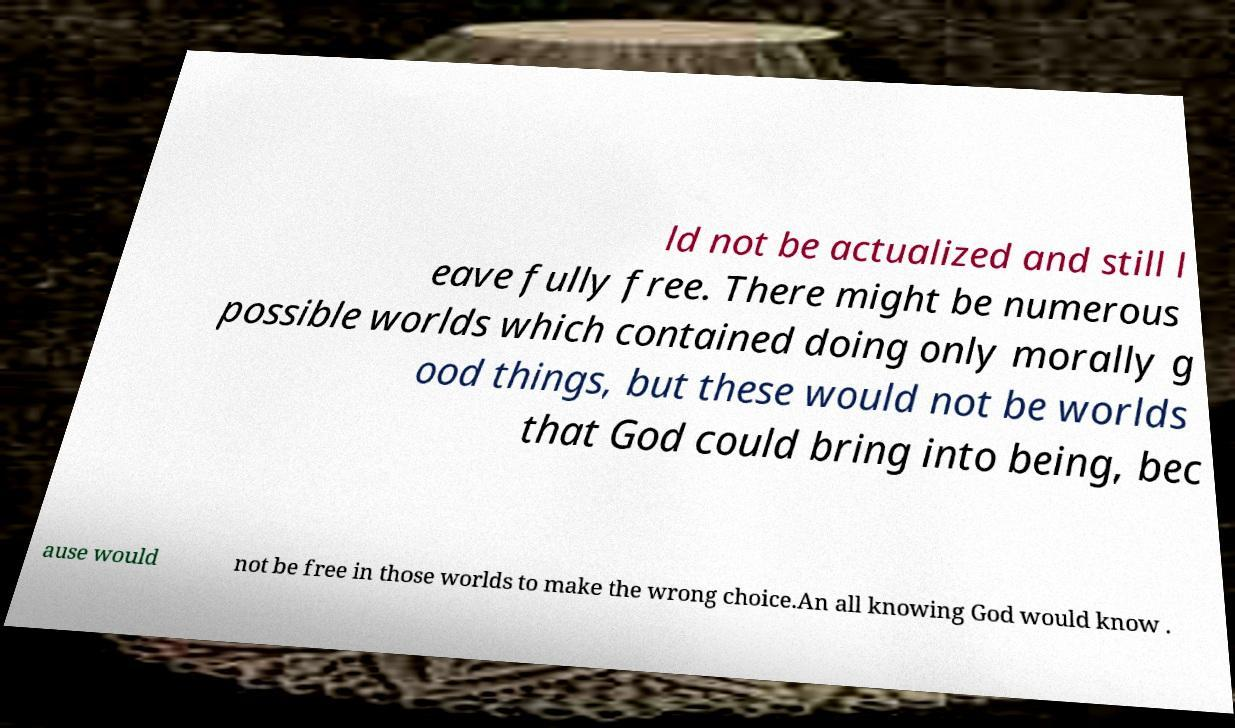What messages or text are displayed in this image? I need them in a readable, typed format. ld not be actualized and still l eave fully free. There might be numerous possible worlds which contained doing only morally g ood things, but these would not be worlds that God could bring into being, bec ause would not be free in those worlds to make the wrong choice.An all knowing God would know . 